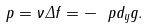Convert formula to latex. <formula><loc_0><loc_0><loc_500><loc_500>p = \nu \Delta f = - \ p d _ { y } g .</formula> 